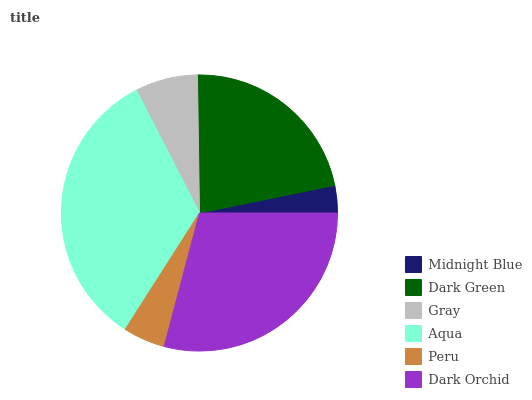Is Midnight Blue the minimum?
Answer yes or no. Yes. Is Aqua the maximum?
Answer yes or no. Yes. Is Dark Green the minimum?
Answer yes or no. No. Is Dark Green the maximum?
Answer yes or no. No. Is Dark Green greater than Midnight Blue?
Answer yes or no. Yes. Is Midnight Blue less than Dark Green?
Answer yes or no. Yes. Is Midnight Blue greater than Dark Green?
Answer yes or no. No. Is Dark Green less than Midnight Blue?
Answer yes or no. No. Is Dark Green the high median?
Answer yes or no. Yes. Is Gray the low median?
Answer yes or no. Yes. Is Midnight Blue the high median?
Answer yes or no. No. Is Aqua the low median?
Answer yes or no. No. 